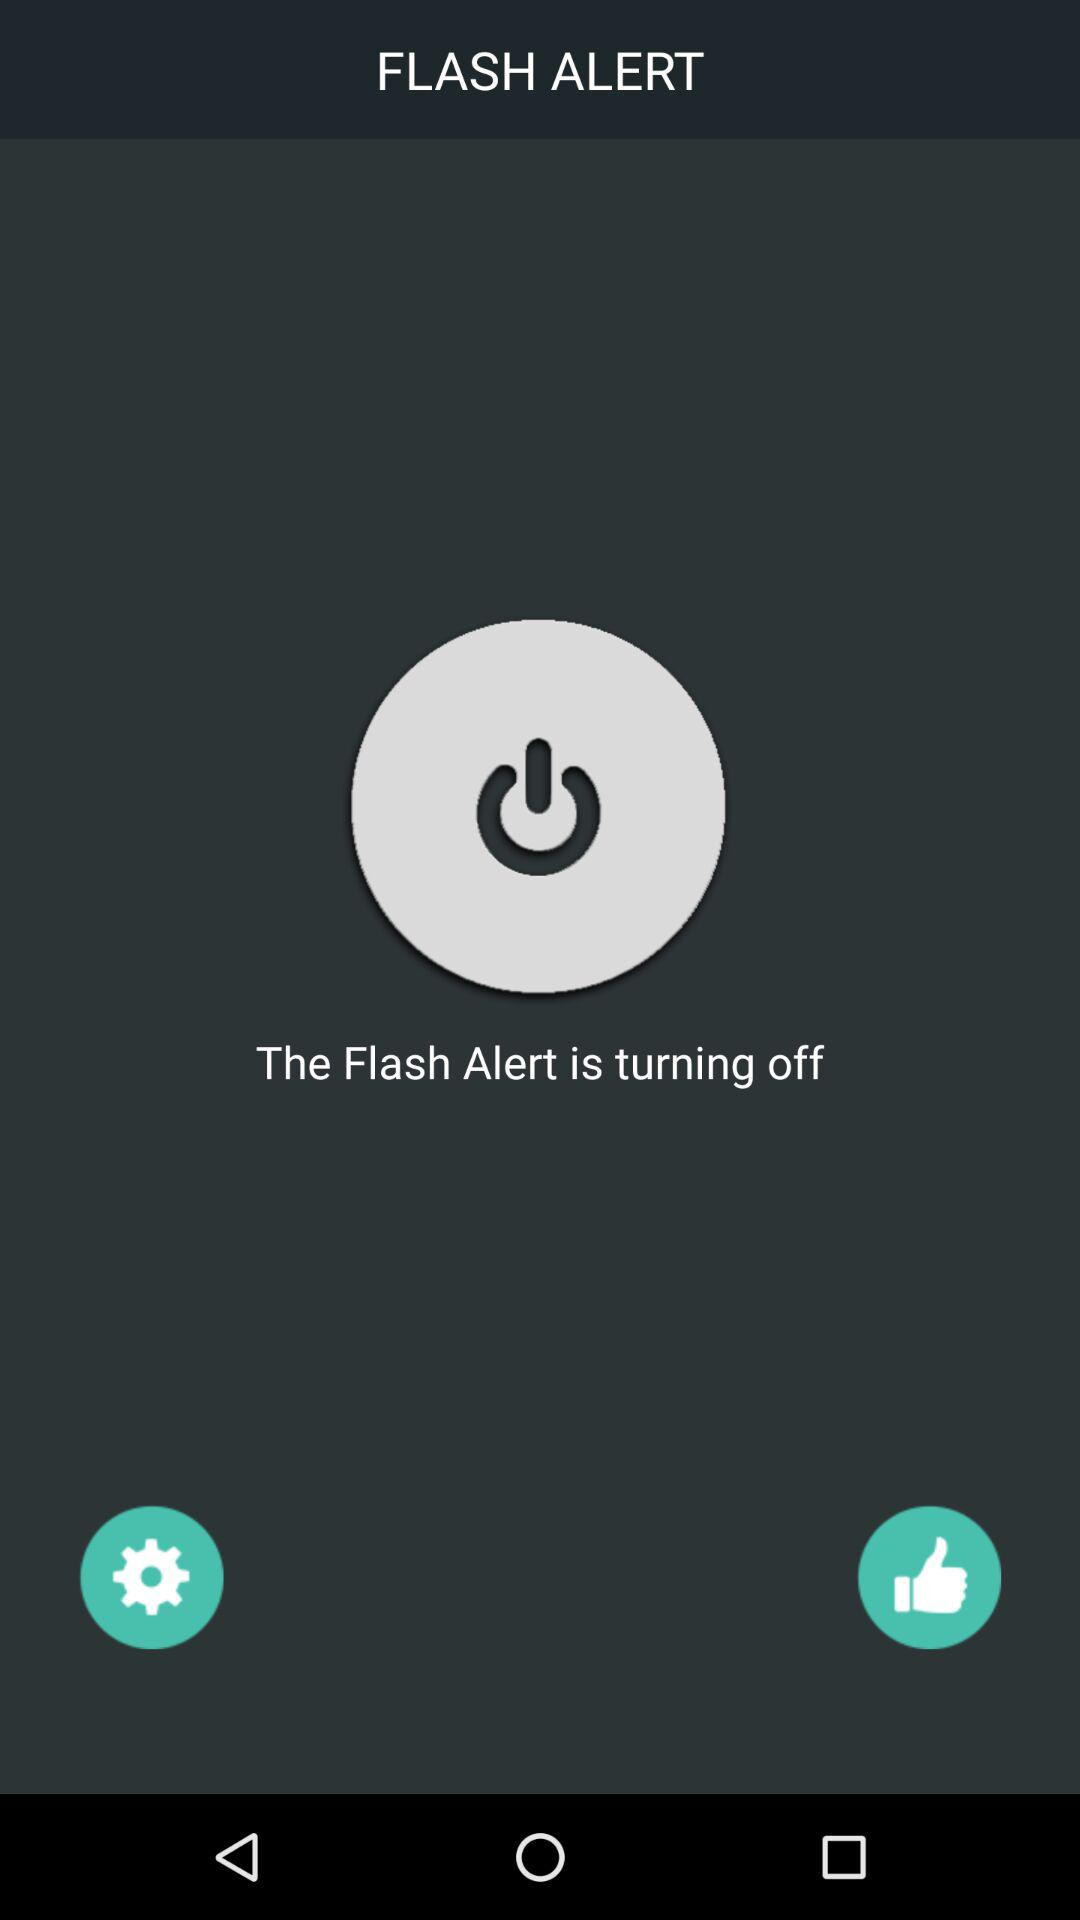How many positive reviews does the "Flash Alert" app have?
When the provided information is insufficient, respond with <no answer>. <no answer> 